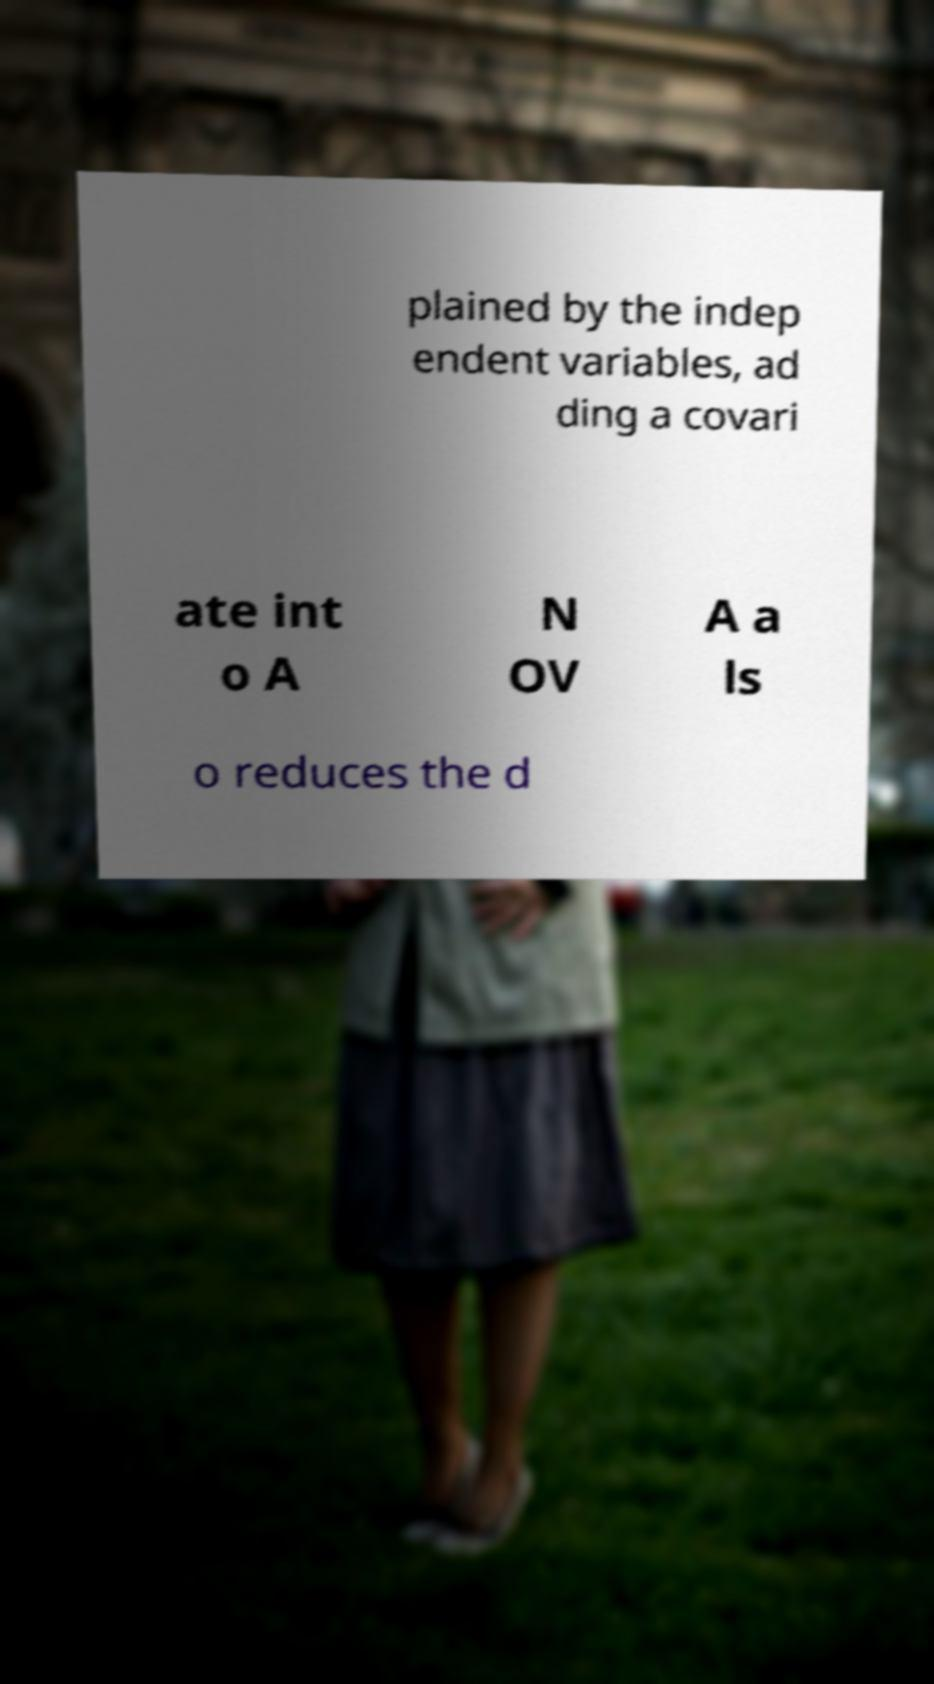For documentation purposes, I need the text within this image transcribed. Could you provide that? plained by the indep endent variables, ad ding a covari ate int o A N OV A a ls o reduces the d 